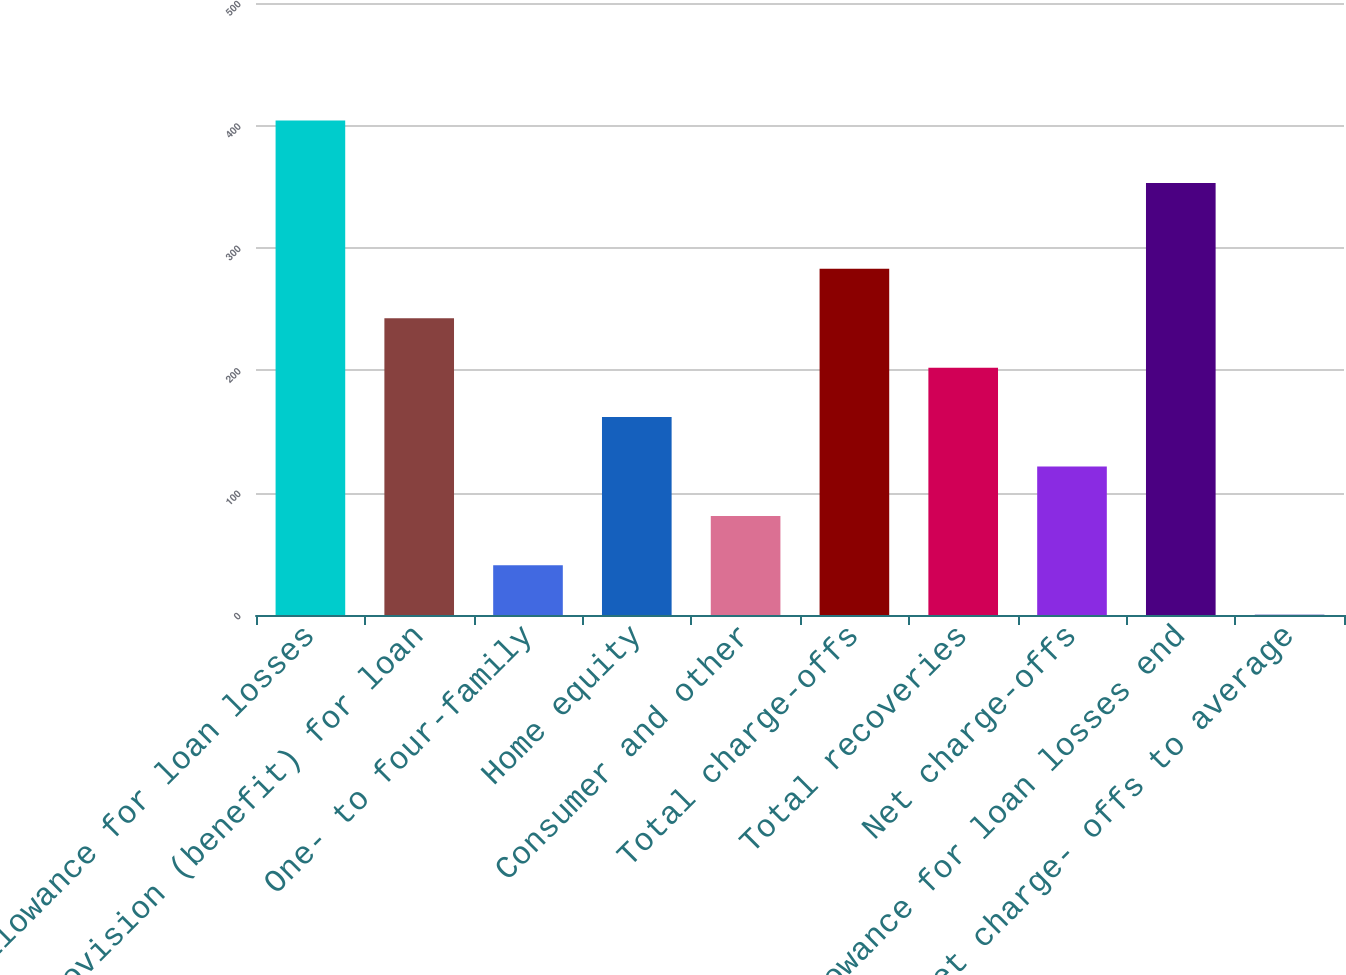<chart> <loc_0><loc_0><loc_500><loc_500><bar_chart><fcel>Allowance for loan losses<fcel>Provision (benefit) for loan<fcel>One- to four-family<fcel>Home equity<fcel>Consumer and other<fcel>Total charge-offs<fcel>Total recoveries<fcel>Net charge-offs<fcel>Allowance for loan losses end<fcel>Net charge- offs to average<nl><fcel>404<fcel>242.48<fcel>40.58<fcel>161.72<fcel>80.96<fcel>282.86<fcel>202.1<fcel>121.34<fcel>353<fcel>0.2<nl></chart> 